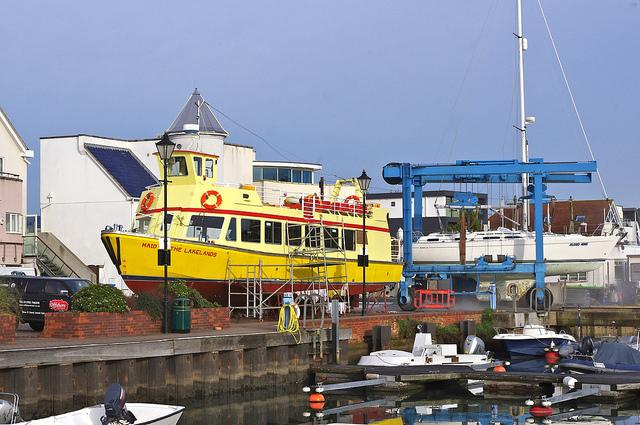What are the red planters on the left made from? Please explain your reasoning. bricks. The planters are brick. 